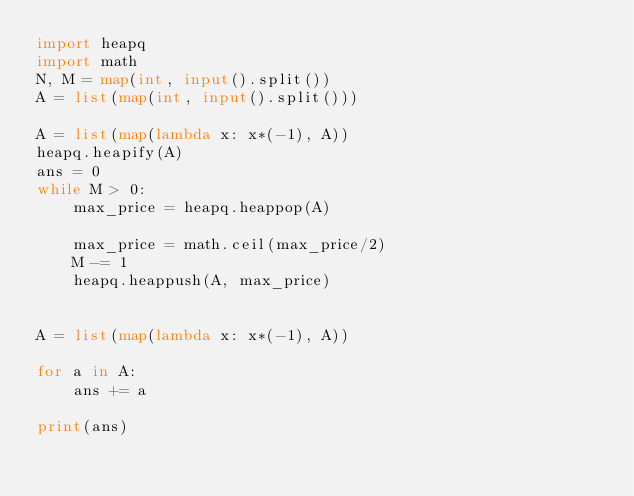Convert code to text. <code><loc_0><loc_0><loc_500><loc_500><_Python_>import heapq
import math
N, M = map(int, input().split())
A = list(map(int, input().split()))

A = list(map(lambda x: x*(-1), A))
heapq.heapify(A)
ans = 0
while M > 0:
    max_price = heapq.heappop(A)

    max_price = math.ceil(max_price/2)
    M -= 1
    heapq.heappush(A, max_price)


A = list(map(lambda x: x*(-1), A))

for a in A:
    ans += a

print(ans)</code> 